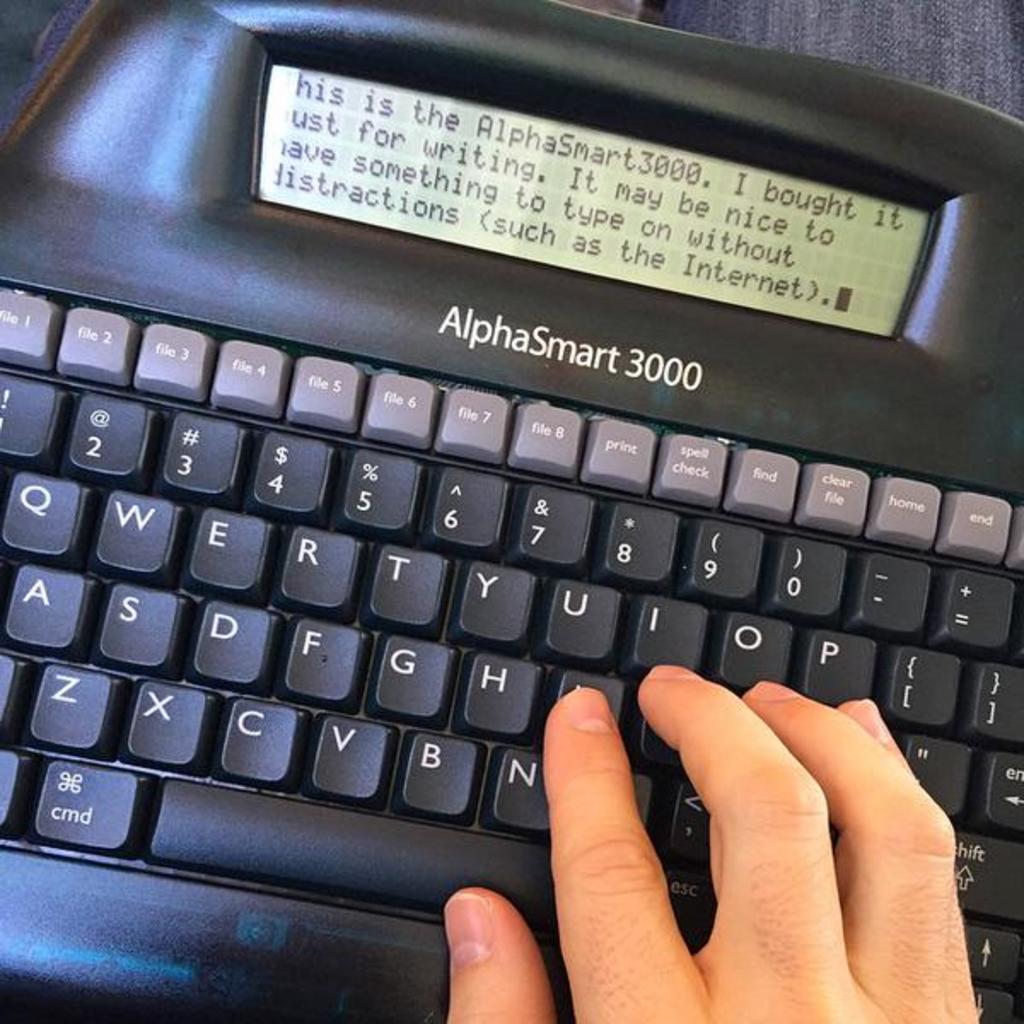What is the name of this electronic device?
Provide a succinct answer. Alphasmart 3000. 